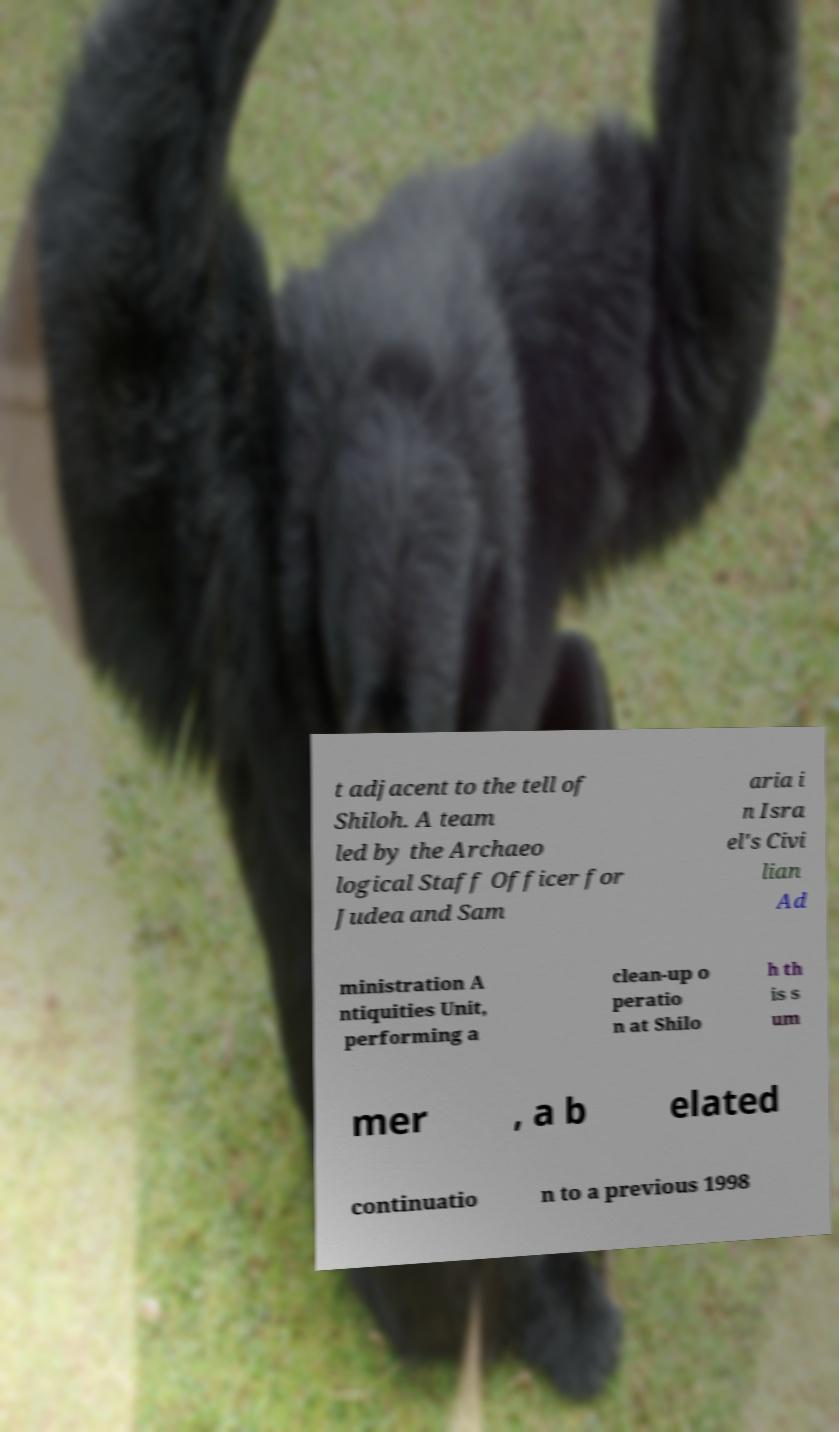For documentation purposes, I need the text within this image transcribed. Could you provide that? t adjacent to the tell of Shiloh. A team led by the Archaeo logical Staff Officer for Judea and Sam aria i n Isra el's Civi lian Ad ministration A ntiquities Unit, performing a clean-up o peratio n at Shilo h th is s um mer , a b elated continuatio n to a previous 1998 